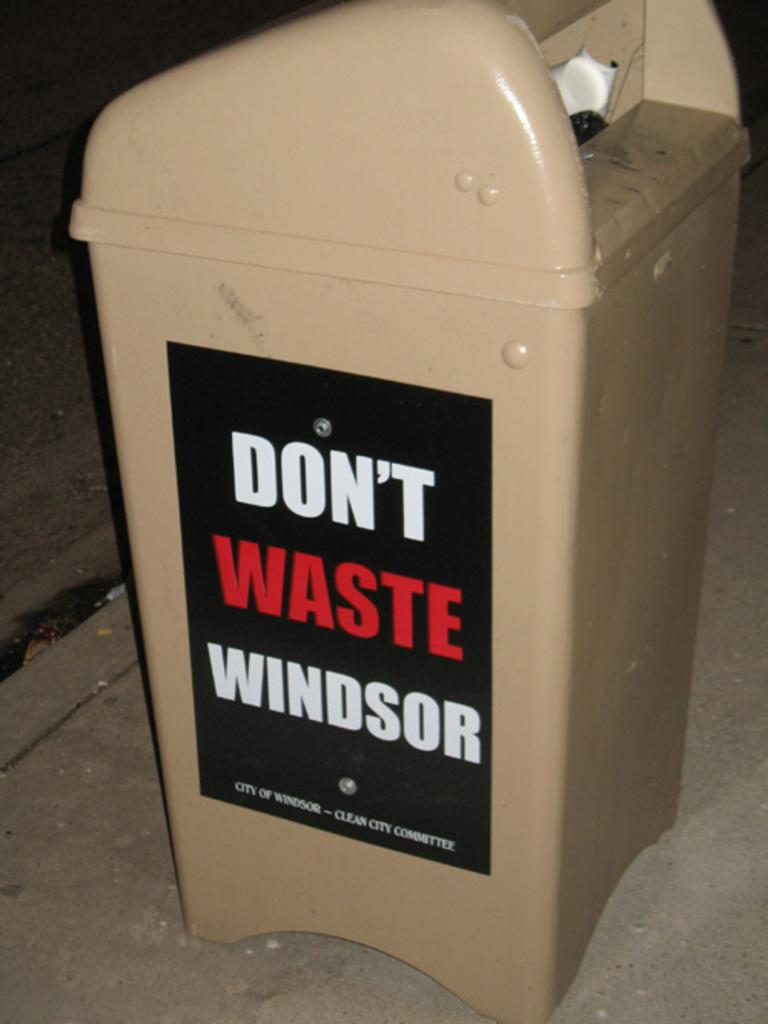<image>
Create a compact narrative representing the image presented. A trash bin with Don't Waste Windsor on a poster on the side. 